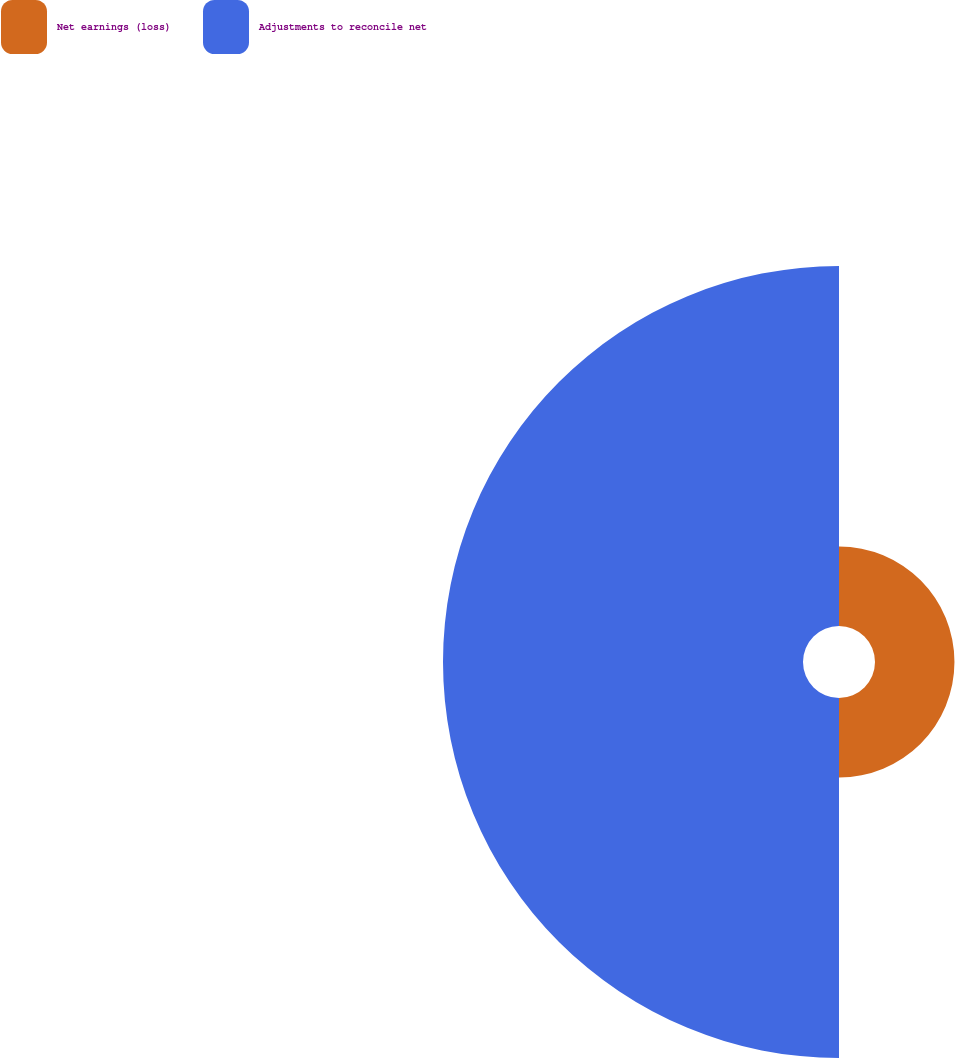Convert chart. <chart><loc_0><loc_0><loc_500><loc_500><pie_chart><fcel>Net earnings (loss)<fcel>Adjustments to reconcile net<nl><fcel>18.08%<fcel>81.92%<nl></chart> 